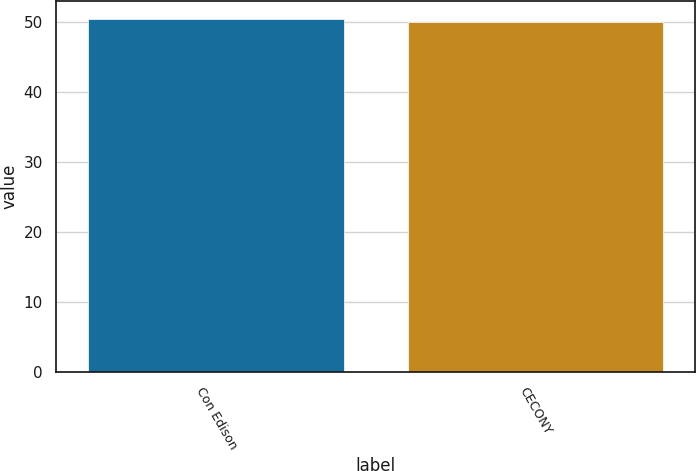Convert chart. <chart><loc_0><loc_0><loc_500><loc_500><bar_chart><fcel>Con Edison<fcel>CECONY<nl><fcel>50.4<fcel>49.9<nl></chart> 